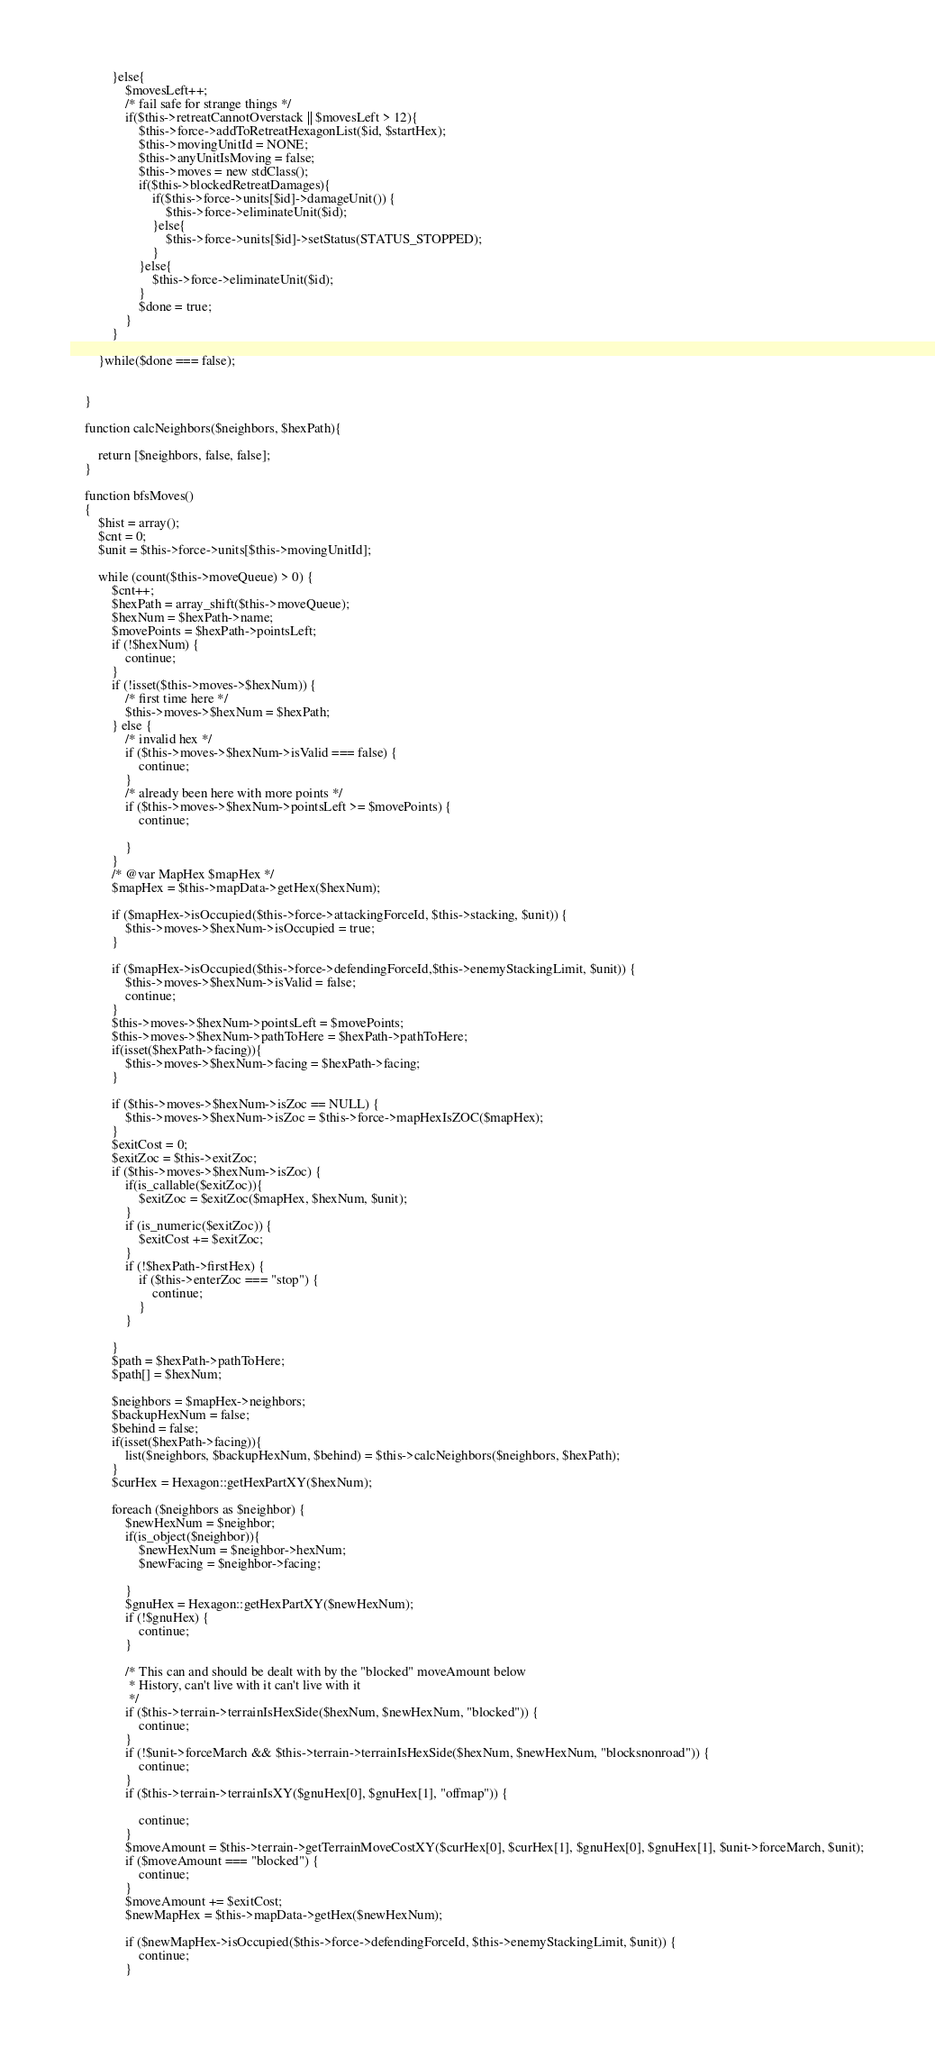<code> <loc_0><loc_0><loc_500><loc_500><_PHP_>            }else{
                $movesLeft++;
                /* fail safe for strange things */
                if($this->retreatCannotOverstack || $movesLeft > 12){
                    $this->force->addToRetreatHexagonList($id, $startHex);
                    $this->movingUnitId = NONE;
                    $this->anyUnitIsMoving = false;
                    $this->moves = new stdClass();
                    if($this->blockedRetreatDamages){
                        if($this->force->units[$id]->damageUnit()) {
                            $this->force->eliminateUnit($id);
                        }else{
                            $this->force->units[$id]->setStatus(STATUS_STOPPED);
                        }
                    }else{
                        $this->force->eliminateUnit($id);
                    }
                    $done = true;
                }
            }

        }while($done === false);


    }

    function calcNeighbors($neighbors, $hexPath){

        return [$neighbors, false, false];
    }

    function bfsMoves()
    {
        $hist = array();
        $cnt = 0;
        $unit = $this->force->units[$this->movingUnitId];

        while (count($this->moveQueue) > 0) {
            $cnt++;
            $hexPath = array_shift($this->moveQueue);
            $hexNum = $hexPath->name;
            $movePoints = $hexPath->pointsLeft;
            if (!$hexNum) {
                continue;
            }
            if (!isset($this->moves->$hexNum)) {
                /* first time here */
                $this->moves->$hexNum = $hexPath;
            } else {
                /* invalid hex */
                if ($this->moves->$hexNum->isValid === false) {
                    continue;
                }
                /* already been here with more points */
                if ($this->moves->$hexNum->pointsLeft >= $movePoints) {
                    continue;

                }
            }
            /* @var MapHex $mapHex */
            $mapHex = $this->mapData->getHex($hexNum);

            if ($mapHex->isOccupied($this->force->attackingForceId, $this->stacking, $unit)) {
                $this->moves->$hexNum->isOccupied = true;
            }

            if ($mapHex->isOccupied($this->force->defendingForceId,$this->enemyStackingLimit, $unit)) {
                $this->moves->$hexNum->isValid = false;
                continue;
            }
            $this->moves->$hexNum->pointsLeft = $movePoints;
            $this->moves->$hexNum->pathToHere = $hexPath->pathToHere;
            if(isset($hexPath->facing)){
                $this->moves->$hexNum->facing = $hexPath->facing;
            }

            if ($this->moves->$hexNum->isZoc == NULL) {
                $this->moves->$hexNum->isZoc = $this->force->mapHexIsZOC($mapHex);
            }
            $exitCost = 0;
            $exitZoc = $this->exitZoc;
            if ($this->moves->$hexNum->isZoc) {
                if(is_callable($exitZoc)){
                    $exitZoc = $exitZoc($mapHex, $hexNum, $unit);
                }
                if (is_numeric($exitZoc)) {
                    $exitCost += $exitZoc;
                }
                if (!$hexPath->firstHex) {
                    if ($this->enterZoc === "stop") {
                        continue;
                    }
                }

            }
            $path = $hexPath->pathToHere;
            $path[] = $hexNum;

            $neighbors = $mapHex->neighbors;
            $backupHexNum = false;
            $behind = false;
            if(isset($hexPath->facing)){
                list($neighbors, $backupHexNum, $behind) = $this->calcNeighbors($neighbors, $hexPath);
            }
            $curHex = Hexagon::getHexPartXY($hexNum);

            foreach ($neighbors as $neighbor) {
                $newHexNum = $neighbor;
                if(is_object($neighbor)){
                    $newHexNum = $neighbor->hexNum;
                    $newFacing = $neighbor->facing;

                }
                $gnuHex = Hexagon::getHexPartXY($newHexNum);
                if (!$gnuHex) {
                    continue;
                }

                /* This can and should be dealt with by the "blocked" moveAmount below
                 * History, can't live with it can't live with it
                 */
                if ($this->terrain->terrainIsHexSide($hexNum, $newHexNum, "blocked")) {
                    continue;
                }
                if (!$unit->forceMarch && $this->terrain->terrainIsHexSide($hexNum, $newHexNum, "blocksnonroad")) {
                    continue;
                }
                if ($this->terrain->terrainIsXY($gnuHex[0], $gnuHex[1], "offmap")) {

                    continue;
                }
                $moveAmount = $this->terrain->getTerrainMoveCostXY($curHex[0], $curHex[1], $gnuHex[0], $gnuHex[1], $unit->forceMarch, $unit);
                if ($moveAmount === "blocked") {
                    continue;
                }
                $moveAmount += $exitCost;
                $newMapHex = $this->mapData->getHex($newHexNum);

                if ($newMapHex->isOccupied($this->force->defendingForceId, $this->enemyStackingLimit, $unit)) {
                    continue;
                }
</code> 